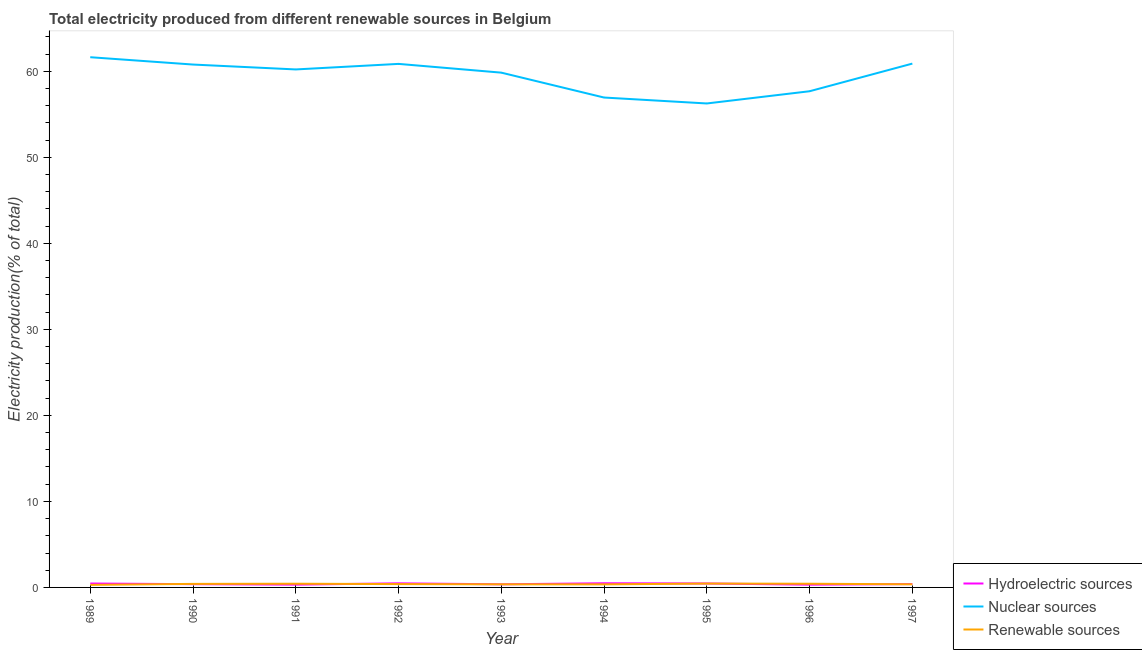How many different coloured lines are there?
Your answer should be very brief. 3. Does the line corresponding to percentage of electricity produced by nuclear sources intersect with the line corresponding to percentage of electricity produced by renewable sources?
Make the answer very short. No. What is the percentage of electricity produced by renewable sources in 1993?
Offer a terse response. 0.36. Across all years, what is the maximum percentage of electricity produced by hydroelectric sources?
Offer a very short reply. 0.48. Across all years, what is the minimum percentage of electricity produced by nuclear sources?
Your response must be concise. 56.25. In which year was the percentage of electricity produced by hydroelectric sources minimum?
Your answer should be very brief. 1996. What is the total percentage of electricity produced by renewable sources in the graph?
Ensure brevity in your answer.  3.48. What is the difference between the percentage of electricity produced by hydroelectric sources in 1991 and that in 1995?
Give a very brief answer. -0.14. What is the difference between the percentage of electricity produced by hydroelectric sources in 1995 and the percentage of electricity produced by nuclear sources in 1991?
Your answer should be very brief. -59.75. What is the average percentage of electricity produced by hydroelectric sources per year?
Make the answer very short. 0.41. In the year 1995, what is the difference between the percentage of electricity produced by hydroelectric sources and percentage of electricity produced by nuclear sources?
Offer a terse response. -55.79. What is the ratio of the percentage of electricity produced by hydroelectric sources in 1993 to that in 1996?
Give a very brief answer. 1.14. Is the percentage of electricity produced by renewable sources in 1992 less than that in 1995?
Your answer should be very brief. Yes. Is the difference between the percentage of electricity produced by nuclear sources in 1990 and 1991 greater than the difference between the percentage of electricity produced by hydroelectric sources in 1990 and 1991?
Offer a very short reply. Yes. What is the difference between the highest and the second highest percentage of electricity produced by nuclear sources?
Your response must be concise. 0.74. What is the difference between the highest and the lowest percentage of electricity produced by hydroelectric sources?
Make the answer very short. 0.17. Is the sum of the percentage of electricity produced by nuclear sources in 1990 and 1992 greater than the maximum percentage of electricity produced by renewable sources across all years?
Your answer should be very brief. Yes. Is it the case that in every year, the sum of the percentage of electricity produced by hydroelectric sources and percentage of electricity produced by nuclear sources is greater than the percentage of electricity produced by renewable sources?
Ensure brevity in your answer.  Yes. Does the percentage of electricity produced by nuclear sources monotonically increase over the years?
Your response must be concise. No. Is the percentage of electricity produced by renewable sources strictly greater than the percentage of electricity produced by hydroelectric sources over the years?
Provide a succinct answer. No. How many lines are there?
Your answer should be very brief. 3. Are the values on the major ticks of Y-axis written in scientific E-notation?
Provide a short and direct response. No. Does the graph contain any zero values?
Your answer should be very brief. No. Where does the legend appear in the graph?
Keep it short and to the point. Bottom right. How many legend labels are there?
Offer a terse response. 3. What is the title of the graph?
Offer a terse response. Total electricity produced from different renewable sources in Belgium. Does "Liquid fuel" appear as one of the legend labels in the graph?
Offer a very short reply. No. What is the label or title of the Y-axis?
Offer a terse response. Electricity production(% of total). What is the Electricity production(% of total) in Hydroelectric sources in 1989?
Offer a terse response. 0.46. What is the Electricity production(% of total) in Nuclear sources in 1989?
Keep it short and to the point. 61.63. What is the Electricity production(% of total) of Renewable sources in 1989?
Provide a short and direct response. 0.3. What is the Electricity production(% of total) of Hydroelectric sources in 1990?
Your response must be concise. 0.38. What is the Electricity production(% of total) of Nuclear sources in 1990?
Offer a very short reply. 60.78. What is the Electricity production(% of total) of Renewable sources in 1990?
Give a very brief answer. 0.41. What is the Electricity production(% of total) of Hydroelectric sources in 1991?
Ensure brevity in your answer.  0.32. What is the Electricity production(% of total) in Nuclear sources in 1991?
Offer a terse response. 60.21. What is the Electricity production(% of total) in Renewable sources in 1991?
Give a very brief answer. 0.43. What is the Electricity production(% of total) of Hydroelectric sources in 1992?
Offer a very short reply. 0.48. What is the Electricity production(% of total) of Nuclear sources in 1992?
Provide a succinct answer. 60.85. What is the Electricity production(% of total) of Renewable sources in 1992?
Offer a terse response. 0.39. What is the Electricity production(% of total) of Hydroelectric sources in 1993?
Ensure brevity in your answer.  0.36. What is the Electricity production(% of total) of Nuclear sources in 1993?
Your response must be concise. 59.84. What is the Electricity production(% of total) in Renewable sources in 1993?
Provide a succinct answer. 0.36. What is the Electricity production(% of total) in Hydroelectric sources in 1994?
Offer a terse response. 0.48. What is the Electricity production(% of total) in Nuclear sources in 1994?
Ensure brevity in your answer.  56.94. What is the Electricity production(% of total) of Renewable sources in 1994?
Make the answer very short. 0.36. What is the Electricity production(% of total) of Hydroelectric sources in 1995?
Offer a very short reply. 0.46. What is the Electricity production(% of total) in Nuclear sources in 1995?
Give a very brief answer. 56.25. What is the Electricity production(% of total) of Renewable sources in 1995?
Keep it short and to the point. 0.45. What is the Electricity production(% of total) in Hydroelectric sources in 1996?
Your answer should be compact. 0.32. What is the Electricity production(% of total) in Nuclear sources in 1996?
Ensure brevity in your answer.  57.68. What is the Electricity production(% of total) of Renewable sources in 1996?
Keep it short and to the point. 0.43. What is the Electricity production(% of total) in Hydroelectric sources in 1997?
Offer a terse response. 0.39. What is the Electricity production(% of total) of Nuclear sources in 1997?
Provide a short and direct response. 60.89. What is the Electricity production(% of total) in Renewable sources in 1997?
Your response must be concise. 0.36. Across all years, what is the maximum Electricity production(% of total) in Hydroelectric sources?
Your answer should be compact. 0.48. Across all years, what is the maximum Electricity production(% of total) in Nuclear sources?
Your answer should be compact. 61.63. Across all years, what is the maximum Electricity production(% of total) of Renewable sources?
Your response must be concise. 0.45. Across all years, what is the minimum Electricity production(% of total) in Hydroelectric sources?
Your response must be concise. 0.32. Across all years, what is the minimum Electricity production(% of total) of Nuclear sources?
Ensure brevity in your answer.  56.25. Across all years, what is the minimum Electricity production(% of total) of Renewable sources?
Offer a very short reply. 0.3. What is the total Electricity production(% of total) in Hydroelectric sources in the graph?
Keep it short and to the point. 3.65. What is the total Electricity production(% of total) of Nuclear sources in the graph?
Make the answer very short. 535.07. What is the total Electricity production(% of total) of Renewable sources in the graph?
Provide a short and direct response. 3.48. What is the difference between the Electricity production(% of total) in Hydroelectric sources in 1989 and that in 1990?
Provide a succinct answer. 0.08. What is the difference between the Electricity production(% of total) in Nuclear sources in 1989 and that in 1990?
Your answer should be compact. 0.85. What is the difference between the Electricity production(% of total) of Renewable sources in 1989 and that in 1990?
Provide a succinct answer. -0.12. What is the difference between the Electricity production(% of total) of Hydroelectric sources in 1989 and that in 1991?
Keep it short and to the point. 0.13. What is the difference between the Electricity production(% of total) in Nuclear sources in 1989 and that in 1991?
Ensure brevity in your answer.  1.42. What is the difference between the Electricity production(% of total) in Renewable sources in 1989 and that in 1991?
Ensure brevity in your answer.  -0.14. What is the difference between the Electricity production(% of total) of Hydroelectric sources in 1989 and that in 1992?
Offer a very short reply. -0.02. What is the difference between the Electricity production(% of total) in Nuclear sources in 1989 and that in 1992?
Provide a succinct answer. 0.78. What is the difference between the Electricity production(% of total) of Renewable sources in 1989 and that in 1992?
Your answer should be very brief. -0.09. What is the difference between the Electricity production(% of total) of Hydroelectric sources in 1989 and that in 1993?
Your answer should be very brief. 0.09. What is the difference between the Electricity production(% of total) of Nuclear sources in 1989 and that in 1993?
Make the answer very short. 1.79. What is the difference between the Electricity production(% of total) of Renewable sources in 1989 and that in 1993?
Provide a succinct answer. -0.07. What is the difference between the Electricity production(% of total) of Hydroelectric sources in 1989 and that in 1994?
Offer a very short reply. -0.03. What is the difference between the Electricity production(% of total) of Nuclear sources in 1989 and that in 1994?
Offer a terse response. 4.69. What is the difference between the Electricity production(% of total) of Renewable sources in 1989 and that in 1994?
Make the answer very short. -0.06. What is the difference between the Electricity production(% of total) in Hydroelectric sources in 1989 and that in 1995?
Offer a terse response. -0. What is the difference between the Electricity production(% of total) of Nuclear sources in 1989 and that in 1995?
Keep it short and to the point. 5.38. What is the difference between the Electricity production(% of total) of Renewable sources in 1989 and that in 1995?
Keep it short and to the point. -0.15. What is the difference between the Electricity production(% of total) in Hydroelectric sources in 1989 and that in 1996?
Make the answer very short. 0.14. What is the difference between the Electricity production(% of total) in Nuclear sources in 1989 and that in 1996?
Provide a short and direct response. 3.96. What is the difference between the Electricity production(% of total) in Renewable sources in 1989 and that in 1996?
Your answer should be very brief. -0.13. What is the difference between the Electricity production(% of total) of Hydroelectric sources in 1989 and that in 1997?
Provide a succinct answer. 0.06. What is the difference between the Electricity production(% of total) in Nuclear sources in 1989 and that in 1997?
Keep it short and to the point. 0.74. What is the difference between the Electricity production(% of total) of Renewable sources in 1989 and that in 1997?
Provide a succinct answer. -0.07. What is the difference between the Electricity production(% of total) of Hydroelectric sources in 1990 and that in 1991?
Provide a short and direct response. 0.06. What is the difference between the Electricity production(% of total) in Nuclear sources in 1990 and that in 1991?
Your answer should be compact. 0.57. What is the difference between the Electricity production(% of total) in Renewable sources in 1990 and that in 1991?
Offer a very short reply. -0.02. What is the difference between the Electricity production(% of total) of Hydroelectric sources in 1990 and that in 1992?
Your answer should be compact. -0.1. What is the difference between the Electricity production(% of total) of Nuclear sources in 1990 and that in 1992?
Your response must be concise. -0.08. What is the difference between the Electricity production(% of total) of Renewable sources in 1990 and that in 1992?
Make the answer very short. 0.02. What is the difference between the Electricity production(% of total) in Hydroelectric sources in 1990 and that in 1993?
Your response must be concise. 0.02. What is the difference between the Electricity production(% of total) of Nuclear sources in 1990 and that in 1993?
Provide a succinct answer. 0.94. What is the difference between the Electricity production(% of total) of Renewable sources in 1990 and that in 1993?
Offer a terse response. 0.05. What is the difference between the Electricity production(% of total) in Hydroelectric sources in 1990 and that in 1994?
Your answer should be very brief. -0.11. What is the difference between the Electricity production(% of total) in Nuclear sources in 1990 and that in 1994?
Make the answer very short. 3.83. What is the difference between the Electricity production(% of total) in Renewable sources in 1990 and that in 1994?
Offer a terse response. 0.06. What is the difference between the Electricity production(% of total) of Hydroelectric sources in 1990 and that in 1995?
Your answer should be compact. -0.08. What is the difference between the Electricity production(% of total) in Nuclear sources in 1990 and that in 1995?
Make the answer very short. 4.52. What is the difference between the Electricity production(% of total) of Renewable sources in 1990 and that in 1995?
Ensure brevity in your answer.  -0.04. What is the difference between the Electricity production(% of total) of Hydroelectric sources in 1990 and that in 1996?
Your answer should be compact. 0.06. What is the difference between the Electricity production(% of total) in Nuclear sources in 1990 and that in 1996?
Make the answer very short. 3.1. What is the difference between the Electricity production(% of total) of Renewable sources in 1990 and that in 1996?
Your answer should be very brief. -0.02. What is the difference between the Electricity production(% of total) in Hydroelectric sources in 1990 and that in 1997?
Provide a short and direct response. -0.01. What is the difference between the Electricity production(% of total) of Nuclear sources in 1990 and that in 1997?
Provide a succinct answer. -0.11. What is the difference between the Electricity production(% of total) in Renewable sources in 1990 and that in 1997?
Ensure brevity in your answer.  0.05. What is the difference between the Electricity production(% of total) in Hydroelectric sources in 1991 and that in 1992?
Offer a terse response. -0.16. What is the difference between the Electricity production(% of total) of Nuclear sources in 1991 and that in 1992?
Your answer should be compact. -0.64. What is the difference between the Electricity production(% of total) in Renewable sources in 1991 and that in 1992?
Provide a short and direct response. 0.04. What is the difference between the Electricity production(% of total) of Hydroelectric sources in 1991 and that in 1993?
Offer a terse response. -0.04. What is the difference between the Electricity production(% of total) of Nuclear sources in 1991 and that in 1993?
Provide a succinct answer. 0.37. What is the difference between the Electricity production(% of total) of Renewable sources in 1991 and that in 1993?
Offer a terse response. 0.07. What is the difference between the Electricity production(% of total) in Hydroelectric sources in 1991 and that in 1994?
Keep it short and to the point. -0.16. What is the difference between the Electricity production(% of total) of Nuclear sources in 1991 and that in 1994?
Offer a terse response. 3.27. What is the difference between the Electricity production(% of total) of Renewable sources in 1991 and that in 1994?
Give a very brief answer. 0.08. What is the difference between the Electricity production(% of total) in Hydroelectric sources in 1991 and that in 1995?
Your response must be concise. -0.14. What is the difference between the Electricity production(% of total) in Nuclear sources in 1991 and that in 1995?
Your answer should be very brief. 3.96. What is the difference between the Electricity production(% of total) of Renewable sources in 1991 and that in 1995?
Your answer should be compact. -0.02. What is the difference between the Electricity production(% of total) of Hydroelectric sources in 1991 and that in 1996?
Make the answer very short. 0. What is the difference between the Electricity production(% of total) in Nuclear sources in 1991 and that in 1996?
Ensure brevity in your answer.  2.53. What is the difference between the Electricity production(% of total) in Renewable sources in 1991 and that in 1996?
Provide a succinct answer. 0. What is the difference between the Electricity production(% of total) in Hydroelectric sources in 1991 and that in 1997?
Offer a very short reply. -0.07. What is the difference between the Electricity production(% of total) in Nuclear sources in 1991 and that in 1997?
Provide a succinct answer. -0.68. What is the difference between the Electricity production(% of total) of Renewable sources in 1991 and that in 1997?
Give a very brief answer. 0.07. What is the difference between the Electricity production(% of total) of Hydroelectric sources in 1992 and that in 1993?
Offer a terse response. 0.12. What is the difference between the Electricity production(% of total) of Nuclear sources in 1992 and that in 1993?
Your answer should be very brief. 1.02. What is the difference between the Electricity production(% of total) in Renewable sources in 1992 and that in 1993?
Ensure brevity in your answer.  0.03. What is the difference between the Electricity production(% of total) of Hydroelectric sources in 1992 and that in 1994?
Give a very brief answer. -0.01. What is the difference between the Electricity production(% of total) of Nuclear sources in 1992 and that in 1994?
Your answer should be very brief. 3.91. What is the difference between the Electricity production(% of total) of Renewable sources in 1992 and that in 1994?
Keep it short and to the point. 0.03. What is the difference between the Electricity production(% of total) in Hydroelectric sources in 1992 and that in 1995?
Your answer should be very brief. 0.02. What is the difference between the Electricity production(% of total) of Nuclear sources in 1992 and that in 1995?
Keep it short and to the point. 4.6. What is the difference between the Electricity production(% of total) in Renewable sources in 1992 and that in 1995?
Your response must be concise. -0.06. What is the difference between the Electricity production(% of total) in Hydroelectric sources in 1992 and that in 1996?
Give a very brief answer. 0.16. What is the difference between the Electricity production(% of total) in Nuclear sources in 1992 and that in 1996?
Your answer should be very brief. 3.18. What is the difference between the Electricity production(% of total) of Renewable sources in 1992 and that in 1996?
Your answer should be compact. -0.04. What is the difference between the Electricity production(% of total) in Hydroelectric sources in 1992 and that in 1997?
Make the answer very short. 0.09. What is the difference between the Electricity production(% of total) in Nuclear sources in 1992 and that in 1997?
Offer a terse response. -0.03. What is the difference between the Electricity production(% of total) of Renewable sources in 1992 and that in 1997?
Your answer should be compact. 0.02. What is the difference between the Electricity production(% of total) of Hydroelectric sources in 1993 and that in 1994?
Provide a short and direct response. -0.12. What is the difference between the Electricity production(% of total) in Nuclear sources in 1993 and that in 1994?
Offer a very short reply. 2.89. What is the difference between the Electricity production(% of total) in Renewable sources in 1993 and that in 1994?
Offer a very short reply. 0.01. What is the difference between the Electricity production(% of total) of Hydroelectric sources in 1993 and that in 1995?
Provide a succinct answer. -0.1. What is the difference between the Electricity production(% of total) in Nuclear sources in 1993 and that in 1995?
Your answer should be compact. 3.58. What is the difference between the Electricity production(% of total) in Renewable sources in 1993 and that in 1995?
Your answer should be compact. -0.09. What is the difference between the Electricity production(% of total) in Hydroelectric sources in 1993 and that in 1996?
Provide a succinct answer. 0.04. What is the difference between the Electricity production(% of total) of Nuclear sources in 1993 and that in 1996?
Give a very brief answer. 2.16. What is the difference between the Electricity production(% of total) of Renewable sources in 1993 and that in 1996?
Provide a succinct answer. -0.07. What is the difference between the Electricity production(% of total) of Hydroelectric sources in 1993 and that in 1997?
Make the answer very short. -0.03. What is the difference between the Electricity production(% of total) in Nuclear sources in 1993 and that in 1997?
Your answer should be compact. -1.05. What is the difference between the Electricity production(% of total) in Renewable sources in 1993 and that in 1997?
Your response must be concise. -0. What is the difference between the Electricity production(% of total) of Hydroelectric sources in 1994 and that in 1995?
Offer a terse response. 0.03. What is the difference between the Electricity production(% of total) in Nuclear sources in 1994 and that in 1995?
Your response must be concise. 0.69. What is the difference between the Electricity production(% of total) of Renewable sources in 1994 and that in 1995?
Keep it short and to the point. -0.09. What is the difference between the Electricity production(% of total) in Hydroelectric sources in 1994 and that in 1996?
Keep it short and to the point. 0.17. What is the difference between the Electricity production(% of total) of Nuclear sources in 1994 and that in 1996?
Your response must be concise. -0.73. What is the difference between the Electricity production(% of total) in Renewable sources in 1994 and that in 1996?
Provide a short and direct response. -0.07. What is the difference between the Electricity production(% of total) of Hydroelectric sources in 1994 and that in 1997?
Offer a terse response. 0.09. What is the difference between the Electricity production(% of total) in Nuclear sources in 1994 and that in 1997?
Provide a succinct answer. -3.94. What is the difference between the Electricity production(% of total) of Renewable sources in 1994 and that in 1997?
Provide a short and direct response. -0.01. What is the difference between the Electricity production(% of total) of Hydroelectric sources in 1995 and that in 1996?
Make the answer very short. 0.14. What is the difference between the Electricity production(% of total) in Nuclear sources in 1995 and that in 1996?
Your answer should be compact. -1.42. What is the difference between the Electricity production(% of total) of Renewable sources in 1995 and that in 1996?
Provide a succinct answer. 0.02. What is the difference between the Electricity production(% of total) of Hydroelectric sources in 1995 and that in 1997?
Offer a terse response. 0.07. What is the difference between the Electricity production(% of total) in Nuclear sources in 1995 and that in 1997?
Your response must be concise. -4.63. What is the difference between the Electricity production(% of total) of Renewable sources in 1995 and that in 1997?
Offer a very short reply. 0.09. What is the difference between the Electricity production(% of total) in Hydroelectric sources in 1996 and that in 1997?
Ensure brevity in your answer.  -0.07. What is the difference between the Electricity production(% of total) in Nuclear sources in 1996 and that in 1997?
Offer a very short reply. -3.21. What is the difference between the Electricity production(% of total) in Renewable sources in 1996 and that in 1997?
Give a very brief answer. 0.07. What is the difference between the Electricity production(% of total) in Hydroelectric sources in 1989 and the Electricity production(% of total) in Nuclear sources in 1990?
Ensure brevity in your answer.  -60.32. What is the difference between the Electricity production(% of total) in Hydroelectric sources in 1989 and the Electricity production(% of total) in Renewable sources in 1990?
Keep it short and to the point. 0.04. What is the difference between the Electricity production(% of total) in Nuclear sources in 1989 and the Electricity production(% of total) in Renewable sources in 1990?
Offer a very short reply. 61.22. What is the difference between the Electricity production(% of total) in Hydroelectric sources in 1989 and the Electricity production(% of total) in Nuclear sources in 1991?
Offer a terse response. -59.75. What is the difference between the Electricity production(% of total) of Hydroelectric sources in 1989 and the Electricity production(% of total) of Renewable sources in 1991?
Provide a short and direct response. 0.02. What is the difference between the Electricity production(% of total) of Nuclear sources in 1989 and the Electricity production(% of total) of Renewable sources in 1991?
Your response must be concise. 61.2. What is the difference between the Electricity production(% of total) in Hydroelectric sources in 1989 and the Electricity production(% of total) in Nuclear sources in 1992?
Provide a short and direct response. -60.4. What is the difference between the Electricity production(% of total) of Hydroelectric sources in 1989 and the Electricity production(% of total) of Renewable sources in 1992?
Offer a very short reply. 0.07. What is the difference between the Electricity production(% of total) in Nuclear sources in 1989 and the Electricity production(% of total) in Renewable sources in 1992?
Your answer should be very brief. 61.24. What is the difference between the Electricity production(% of total) of Hydroelectric sources in 1989 and the Electricity production(% of total) of Nuclear sources in 1993?
Provide a short and direct response. -59.38. What is the difference between the Electricity production(% of total) in Hydroelectric sources in 1989 and the Electricity production(% of total) in Renewable sources in 1993?
Keep it short and to the point. 0.1. What is the difference between the Electricity production(% of total) of Nuclear sources in 1989 and the Electricity production(% of total) of Renewable sources in 1993?
Your answer should be very brief. 61.27. What is the difference between the Electricity production(% of total) of Hydroelectric sources in 1989 and the Electricity production(% of total) of Nuclear sources in 1994?
Provide a succinct answer. -56.49. What is the difference between the Electricity production(% of total) of Nuclear sources in 1989 and the Electricity production(% of total) of Renewable sources in 1994?
Your answer should be very brief. 61.27. What is the difference between the Electricity production(% of total) in Hydroelectric sources in 1989 and the Electricity production(% of total) in Nuclear sources in 1995?
Your answer should be compact. -55.8. What is the difference between the Electricity production(% of total) of Hydroelectric sources in 1989 and the Electricity production(% of total) of Renewable sources in 1995?
Provide a succinct answer. 0.01. What is the difference between the Electricity production(% of total) in Nuclear sources in 1989 and the Electricity production(% of total) in Renewable sources in 1995?
Give a very brief answer. 61.18. What is the difference between the Electricity production(% of total) of Hydroelectric sources in 1989 and the Electricity production(% of total) of Nuclear sources in 1996?
Your response must be concise. -57.22. What is the difference between the Electricity production(% of total) of Hydroelectric sources in 1989 and the Electricity production(% of total) of Renewable sources in 1996?
Your response must be concise. 0.03. What is the difference between the Electricity production(% of total) of Nuclear sources in 1989 and the Electricity production(% of total) of Renewable sources in 1996?
Give a very brief answer. 61.2. What is the difference between the Electricity production(% of total) in Hydroelectric sources in 1989 and the Electricity production(% of total) in Nuclear sources in 1997?
Give a very brief answer. -60.43. What is the difference between the Electricity production(% of total) of Hydroelectric sources in 1989 and the Electricity production(% of total) of Renewable sources in 1997?
Offer a very short reply. 0.09. What is the difference between the Electricity production(% of total) of Nuclear sources in 1989 and the Electricity production(% of total) of Renewable sources in 1997?
Give a very brief answer. 61.27. What is the difference between the Electricity production(% of total) in Hydroelectric sources in 1990 and the Electricity production(% of total) in Nuclear sources in 1991?
Offer a terse response. -59.83. What is the difference between the Electricity production(% of total) of Hydroelectric sources in 1990 and the Electricity production(% of total) of Renewable sources in 1991?
Your answer should be compact. -0.05. What is the difference between the Electricity production(% of total) in Nuclear sources in 1990 and the Electricity production(% of total) in Renewable sources in 1991?
Offer a terse response. 60.35. What is the difference between the Electricity production(% of total) in Hydroelectric sources in 1990 and the Electricity production(% of total) in Nuclear sources in 1992?
Offer a terse response. -60.48. What is the difference between the Electricity production(% of total) in Hydroelectric sources in 1990 and the Electricity production(% of total) in Renewable sources in 1992?
Ensure brevity in your answer.  -0.01. What is the difference between the Electricity production(% of total) of Nuclear sources in 1990 and the Electricity production(% of total) of Renewable sources in 1992?
Your answer should be compact. 60.39. What is the difference between the Electricity production(% of total) of Hydroelectric sources in 1990 and the Electricity production(% of total) of Nuclear sources in 1993?
Your response must be concise. -59.46. What is the difference between the Electricity production(% of total) in Hydroelectric sources in 1990 and the Electricity production(% of total) in Renewable sources in 1993?
Give a very brief answer. 0.02. What is the difference between the Electricity production(% of total) in Nuclear sources in 1990 and the Electricity production(% of total) in Renewable sources in 1993?
Provide a succinct answer. 60.42. What is the difference between the Electricity production(% of total) in Hydroelectric sources in 1990 and the Electricity production(% of total) in Nuclear sources in 1994?
Offer a terse response. -56.56. What is the difference between the Electricity production(% of total) of Hydroelectric sources in 1990 and the Electricity production(% of total) of Renewable sources in 1994?
Your answer should be very brief. 0.02. What is the difference between the Electricity production(% of total) of Nuclear sources in 1990 and the Electricity production(% of total) of Renewable sources in 1994?
Ensure brevity in your answer.  60.42. What is the difference between the Electricity production(% of total) of Hydroelectric sources in 1990 and the Electricity production(% of total) of Nuclear sources in 1995?
Your response must be concise. -55.88. What is the difference between the Electricity production(% of total) in Hydroelectric sources in 1990 and the Electricity production(% of total) in Renewable sources in 1995?
Offer a terse response. -0.07. What is the difference between the Electricity production(% of total) in Nuclear sources in 1990 and the Electricity production(% of total) in Renewable sources in 1995?
Your answer should be compact. 60.33. What is the difference between the Electricity production(% of total) in Hydroelectric sources in 1990 and the Electricity production(% of total) in Nuclear sources in 1996?
Your answer should be very brief. -57.3. What is the difference between the Electricity production(% of total) of Hydroelectric sources in 1990 and the Electricity production(% of total) of Renewable sources in 1996?
Your response must be concise. -0.05. What is the difference between the Electricity production(% of total) in Nuclear sources in 1990 and the Electricity production(% of total) in Renewable sources in 1996?
Your answer should be compact. 60.35. What is the difference between the Electricity production(% of total) in Hydroelectric sources in 1990 and the Electricity production(% of total) in Nuclear sources in 1997?
Provide a short and direct response. -60.51. What is the difference between the Electricity production(% of total) in Hydroelectric sources in 1990 and the Electricity production(% of total) in Renewable sources in 1997?
Your answer should be compact. 0.01. What is the difference between the Electricity production(% of total) in Nuclear sources in 1990 and the Electricity production(% of total) in Renewable sources in 1997?
Provide a succinct answer. 60.41. What is the difference between the Electricity production(% of total) in Hydroelectric sources in 1991 and the Electricity production(% of total) in Nuclear sources in 1992?
Make the answer very short. -60.53. What is the difference between the Electricity production(% of total) of Hydroelectric sources in 1991 and the Electricity production(% of total) of Renewable sources in 1992?
Offer a terse response. -0.06. What is the difference between the Electricity production(% of total) of Nuclear sources in 1991 and the Electricity production(% of total) of Renewable sources in 1992?
Offer a very short reply. 59.82. What is the difference between the Electricity production(% of total) of Hydroelectric sources in 1991 and the Electricity production(% of total) of Nuclear sources in 1993?
Ensure brevity in your answer.  -59.52. What is the difference between the Electricity production(% of total) of Hydroelectric sources in 1991 and the Electricity production(% of total) of Renewable sources in 1993?
Your response must be concise. -0.04. What is the difference between the Electricity production(% of total) of Nuclear sources in 1991 and the Electricity production(% of total) of Renewable sources in 1993?
Your response must be concise. 59.85. What is the difference between the Electricity production(% of total) in Hydroelectric sources in 1991 and the Electricity production(% of total) in Nuclear sources in 1994?
Give a very brief answer. -56.62. What is the difference between the Electricity production(% of total) in Hydroelectric sources in 1991 and the Electricity production(% of total) in Renewable sources in 1994?
Offer a terse response. -0.03. What is the difference between the Electricity production(% of total) in Nuclear sources in 1991 and the Electricity production(% of total) in Renewable sources in 1994?
Your answer should be very brief. 59.85. What is the difference between the Electricity production(% of total) of Hydroelectric sources in 1991 and the Electricity production(% of total) of Nuclear sources in 1995?
Offer a very short reply. -55.93. What is the difference between the Electricity production(% of total) in Hydroelectric sources in 1991 and the Electricity production(% of total) in Renewable sources in 1995?
Offer a very short reply. -0.13. What is the difference between the Electricity production(% of total) in Nuclear sources in 1991 and the Electricity production(% of total) in Renewable sources in 1995?
Offer a very short reply. 59.76. What is the difference between the Electricity production(% of total) of Hydroelectric sources in 1991 and the Electricity production(% of total) of Nuclear sources in 1996?
Offer a terse response. -57.35. What is the difference between the Electricity production(% of total) in Hydroelectric sources in 1991 and the Electricity production(% of total) in Renewable sources in 1996?
Offer a very short reply. -0.11. What is the difference between the Electricity production(% of total) of Nuclear sources in 1991 and the Electricity production(% of total) of Renewable sources in 1996?
Provide a succinct answer. 59.78. What is the difference between the Electricity production(% of total) of Hydroelectric sources in 1991 and the Electricity production(% of total) of Nuclear sources in 1997?
Your response must be concise. -60.57. What is the difference between the Electricity production(% of total) of Hydroelectric sources in 1991 and the Electricity production(% of total) of Renewable sources in 1997?
Your answer should be compact. -0.04. What is the difference between the Electricity production(% of total) in Nuclear sources in 1991 and the Electricity production(% of total) in Renewable sources in 1997?
Provide a short and direct response. 59.85. What is the difference between the Electricity production(% of total) in Hydroelectric sources in 1992 and the Electricity production(% of total) in Nuclear sources in 1993?
Keep it short and to the point. -59.36. What is the difference between the Electricity production(% of total) of Hydroelectric sources in 1992 and the Electricity production(% of total) of Renewable sources in 1993?
Keep it short and to the point. 0.12. What is the difference between the Electricity production(% of total) in Nuclear sources in 1992 and the Electricity production(% of total) in Renewable sources in 1993?
Your response must be concise. 60.49. What is the difference between the Electricity production(% of total) in Hydroelectric sources in 1992 and the Electricity production(% of total) in Nuclear sources in 1994?
Provide a short and direct response. -56.47. What is the difference between the Electricity production(% of total) of Hydroelectric sources in 1992 and the Electricity production(% of total) of Renewable sources in 1994?
Ensure brevity in your answer.  0.12. What is the difference between the Electricity production(% of total) of Nuclear sources in 1992 and the Electricity production(% of total) of Renewable sources in 1994?
Your answer should be compact. 60.5. What is the difference between the Electricity production(% of total) of Hydroelectric sources in 1992 and the Electricity production(% of total) of Nuclear sources in 1995?
Provide a short and direct response. -55.78. What is the difference between the Electricity production(% of total) in Hydroelectric sources in 1992 and the Electricity production(% of total) in Renewable sources in 1995?
Your answer should be compact. 0.03. What is the difference between the Electricity production(% of total) in Nuclear sources in 1992 and the Electricity production(% of total) in Renewable sources in 1995?
Ensure brevity in your answer.  60.41. What is the difference between the Electricity production(% of total) of Hydroelectric sources in 1992 and the Electricity production(% of total) of Nuclear sources in 1996?
Make the answer very short. -57.2. What is the difference between the Electricity production(% of total) of Hydroelectric sources in 1992 and the Electricity production(% of total) of Renewable sources in 1996?
Offer a terse response. 0.05. What is the difference between the Electricity production(% of total) in Nuclear sources in 1992 and the Electricity production(% of total) in Renewable sources in 1996?
Offer a terse response. 60.43. What is the difference between the Electricity production(% of total) in Hydroelectric sources in 1992 and the Electricity production(% of total) in Nuclear sources in 1997?
Keep it short and to the point. -60.41. What is the difference between the Electricity production(% of total) of Hydroelectric sources in 1992 and the Electricity production(% of total) of Renewable sources in 1997?
Your answer should be compact. 0.11. What is the difference between the Electricity production(% of total) in Nuclear sources in 1992 and the Electricity production(% of total) in Renewable sources in 1997?
Provide a succinct answer. 60.49. What is the difference between the Electricity production(% of total) in Hydroelectric sources in 1993 and the Electricity production(% of total) in Nuclear sources in 1994?
Make the answer very short. -56.58. What is the difference between the Electricity production(% of total) of Hydroelectric sources in 1993 and the Electricity production(% of total) of Renewable sources in 1994?
Give a very brief answer. 0.01. What is the difference between the Electricity production(% of total) in Nuclear sources in 1993 and the Electricity production(% of total) in Renewable sources in 1994?
Your response must be concise. 59.48. What is the difference between the Electricity production(% of total) in Hydroelectric sources in 1993 and the Electricity production(% of total) in Nuclear sources in 1995?
Your answer should be very brief. -55.89. What is the difference between the Electricity production(% of total) in Hydroelectric sources in 1993 and the Electricity production(% of total) in Renewable sources in 1995?
Make the answer very short. -0.09. What is the difference between the Electricity production(% of total) of Nuclear sources in 1993 and the Electricity production(% of total) of Renewable sources in 1995?
Offer a terse response. 59.39. What is the difference between the Electricity production(% of total) in Hydroelectric sources in 1993 and the Electricity production(% of total) in Nuclear sources in 1996?
Keep it short and to the point. -57.31. What is the difference between the Electricity production(% of total) in Hydroelectric sources in 1993 and the Electricity production(% of total) in Renewable sources in 1996?
Make the answer very short. -0.07. What is the difference between the Electricity production(% of total) in Nuclear sources in 1993 and the Electricity production(% of total) in Renewable sources in 1996?
Offer a terse response. 59.41. What is the difference between the Electricity production(% of total) of Hydroelectric sources in 1993 and the Electricity production(% of total) of Nuclear sources in 1997?
Provide a short and direct response. -60.53. What is the difference between the Electricity production(% of total) in Hydroelectric sources in 1993 and the Electricity production(% of total) in Renewable sources in 1997?
Your answer should be very brief. -0. What is the difference between the Electricity production(% of total) in Nuclear sources in 1993 and the Electricity production(% of total) in Renewable sources in 1997?
Your response must be concise. 59.47. What is the difference between the Electricity production(% of total) of Hydroelectric sources in 1994 and the Electricity production(% of total) of Nuclear sources in 1995?
Your answer should be very brief. -55.77. What is the difference between the Electricity production(% of total) of Hydroelectric sources in 1994 and the Electricity production(% of total) of Renewable sources in 1995?
Ensure brevity in your answer.  0.04. What is the difference between the Electricity production(% of total) in Nuclear sources in 1994 and the Electricity production(% of total) in Renewable sources in 1995?
Provide a succinct answer. 56.49. What is the difference between the Electricity production(% of total) of Hydroelectric sources in 1994 and the Electricity production(% of total) of Nuclear sources in 1996?
Your response must be concise. -57.19. What is the difference between the Electricity production(% of total) in Hydroelectric sources in 1994 and the Electricity production(% of total) in Renewable sources in 1996?
Give a very brief answer. 0.06. What is the difference between the Electricity production(% of total) in Nuclear sources in 1994 and the Electricity production(% of total) in Renewable sources in 1996?
Keep it short and to the point. 56.51. What is the difference between the Electricity production(% of total) in Hydroelectric sources in 1994 and the Electricity production(% of total) in Nuclear sources in 1997?
Provide a short and direct response. -60.4. What is the difference between the Electricity production(% of total) of Hydroelectric sources in 1994 and the Electricity production(% of total) of Renewable sources in 1997?
Your response must be concise. 0.12. What is the difference between the Electricity production(% of total) in Nuclear sources in 1994 and the Electricity production(% of total) in Renewable sources in 1997?
Ensure brevity in your answer.  56.58. What is the difference between the Electricity production(% of total) of Hydroelectric sources in 1995 and the Electricity production(% of total) of Nuclear sources in 1996?
Your answer should be compact. -57.22. What is the difference between the Electricity production(% of total) in Hydroelectric sources in 1995 and the Electricity production(% of total) in Renewable sources in 1996?
Make the answer very short. 0.03. What is the difference between the Electricity production(% of total) in Nuclear sources in 1995 and the Electricity production(% of total) in Renewable sources in 1996?
Provide a succinct answer. 55.83. What is the difference between the Electricity production(% of total) in Hydroelectric sources in 1995 and the Electricity production(% of total) in Nuclear sources in 1997?
Provide a short and direct response. -60.43. What is the difference between the Electricity production(% of total) in Hydroelectric sources in 1995 and the Electricity production(% of total) in Renewable sources in 1997?
Make the answer very short. 0.1. What is the difference between the Electricity production(% of total) in Nuclear sources in 1995 and the Electricity production(% of total) in Renewable sources in 1997?
Ensure brevity in your answer.  55.89. What is the difference between the Electricity production(% of total) in Hydroelectric sources in 1996 and the Electricity production(% of total) in Nuclear sources in 1997?
Provide a short and direct response. -60.57. What is the difference between the Electricity production(% of total) in Hydroelectric sources in 1996 and the Electricity production(% of total) in Renewable sources in 1997?
Ensure brevity in your answer.  -0.05. What is the difference between the Electricity production(% of total) in Nuclear sources in 1996 and the Electricity production(% of total) in Renewable sources in 1997?
Ensure brevity in your answer.  57.31. What is the average Electricity production(% of total) in Hydroelectric sources per year?
Give a very brief answer. 0.41. What is the average Electricity production(% of total) in Nuclear sources per year?
Your answer should be compact. 59.45. What is the average Electricity production(% of total) of Renewable sources per year?
Make the answer very short. 0.39. In the year 1989, what is the difference between the Electricity production(% of total) in Hydroelectric sources and Electricity production(% of total) in Nuclear sources?
Offer a terse response. -61.17. In the year 1989, what is the difference between the Electricity production(% of total) in Hydroelectric sources and Electricity production(% of total) in Renewable sources?
Your answer should be compact. 0.16. In the year 1989, what is the difference between the Electricity production(% of total) in Nuclear sources and Electricity production(% of total) in Renewable sources?
Offer a terse response. 61.34. In the year 1990, what is the difference between the Electricity production(% of total) in Hydroelectric sources and Electricity production(% of total) in Nuclear sources?
Offer a very short reply. -60.4. In the year 1990, what is the difference between the Electricity production(% of total) in Hydroelectric sources and Electricity production(% of total) in Renewable sources?
Your response must be concise. -0.03. In the year 1990, what is the difference between the Electricity production(% of total) in Nuclear sources and Electricity production(% of total) in Renewable sources?
Ensure brevity in your answer.  60.37. In the year 1991, what is the difference between the Electricity production(% of total) of Hydroelectric sources and Electricity production(% of total) of Nuclear sources?
Give a very brief answer. -59.89. In the year 1991, what is the difference between the Electricity production(% of total) of Hydroelectric sources and Electricity production(% of total) of Renewable sources?
Offer a very short reply. -0.11. In the year 1991, what is the difference between the Electricity production(% of total) of Nuclear sources and Electricity production(% of total) of Renewable sources?
Give a very brief answer. 59.78. In the year 1992, what is the difference between the Electricity production(% of total) in Hydroelectric sources and Electricity production(% of total) in Nuclear sources?
Make the answer very short. -60.38. In the year 1992, what is the difference between the Electricity production(% of total) of Hydroelectric sources and Electricity production(% of total) of Renewable sources?
Your answer should be compact. 0.09. In the year 1992, what is the difference between the Electricity production(% of total) in Nuclear sources and Electricity production(% of total) in Renewable sources?
Provide a succinct answer. 60.47. In the year 1993, what is the difference between the Electricity production(% of total) of Hydroelectric sources and Electricity production(% of total) of Nuclear sources?
Provide a short and direct response. -59.48. In the year 1993, what is the difference between the Electricity production(% of total) of Hydroelectric sources and Electricity production(% of total) of Renewable sources?
Offer a terse response. 0. In the year 1993, what is the difference between the Electricity production(% of total) of Nuclear sources and Electricity production(% of total) of Renewable sources?
Offer a terse response. 59.48. In the year 1994, what is the difference between the Electricity production(% of total) of Hydroelectric sources and Electricity production(% of total) of Nuclear sources?
Give a very brief answer. -56.46. In the year 1994, what is the difference between the Electricity production(% of total) of Hydroelectric sources and Electricity production(% of total) of Renewable sources?
Your answer should be very brief. 0.13. In the year 1994, what is the difference between the Electricity production(% of total) of Nuclear sources and Electricity production(% of total) of Renewable sources?
Provide a succinct answer. 56.59. In the year 1995, what is the difference between the Electricity production(% of total) of Hydroelectric sources and Electricity production(% of total) of Nuclear sources?
Provide a succinct answer. -55.79. In the year 1995, what is the difference between the Electricity production(% of total) of Hydroelectric sources and Electricity production(% of total) of Renewable sources?
Your response must be concise. 0.01. In the year 1995, what is the difference between the Electricity production(% of total) in Nuclear sources and Electricity production(% of total) in Renewable sources?
Give a very brief answer. 55.81. In the year 1996, what is the difference between the Electricity production(% of total) in Hydroelectric sources and Electricity production(% of total) in Nuclear sources?
Give a very brief answer. -57.36. In the year 1996, what is the difference between the Electricity production(% of total) in Hydroelectric sources and Electricity production(% of total) in Renewable sources?
Give a very brief answer. -0.11. In the year 1996, what is the difference between the Electricity production(% of total) in Nuclear sources and Electricity production(% of total) in Renewable sources?
Offer a terse response. 57.25. In the year 1997, what is the difference between the Electricity production(% of total) of Hydroelectric sources and Electricity production(% of total) of Nuclear sources?
Provide a short and direct response. -60.5. In the year 1997, what is the difference between the Electricity production(% of total) in Hydroelectric sources and Electricity production(% of total) in Renewable sources?
Offer a very short reply. 0.03. In the year 1997, what is the difference between the Electricity production(% of total) in Nuclear sources and Electricity production(% of total) in Renewable sources?
Your response must be concise. 60.52. What is the ratio of the Electricity production(% of total) in Hydroelectric sources in 1989 to that in 1990?
Give a very brief answer. 1.21. What is the ratio of the Electricity production(% of total) of Nuclear sources in 1989 to that in 1990?
Give a very brief answer. 1.01. What is the ratio of the Electricity production(% of total) in Renewable sources in 1989 to that in 1990?
Make the answer very short. 0.72. What is the ratio of the Electricity production(% of total) of Hydroelectric sources in 1989 to that in 1991?
Offer a very short reply. 1.42. What is the ratio of the Electricity production(% of total) of Nuclear sources in 1989 to that in 1991?
Provide a short and direct response. 1.02. What is the ratio of the Electricity production(% of total) of Renewable sources in 1989 to that in 1991?
Your answer should be very brief. 0.69. What is the ratio of the Electricity production(% of total) of Hydroelectric sources in 1989 to that in 1992?
Keep it short and to the point. 0.96. What is the ratio of the Electricity production(% of total) in Nuclear sources in 1989 to that in 1992?
Make the answer very short. 1.01. What is the ratio of the Electricity production(% of total) of Renewable sources in 1989 to that in 1992?
Provide a short and direct response. 0.77. What is the ratio of the Electricity production(% of total) of Hydroelectric sources in 1989 to that in 1993?
Your response must be concise. 1.26. What is the ratio of the Electricity production(% of total) in Nuclear sources in 1989 to that in 1993?
Your answer should be compact. 1.03. What is the ratio of the Electricity production(% of total) in Renewable sources in 1989 to that in 1993?
Provide a short and direct response. 0.82. What is the ratio of the Electricity production(% of total) of Hydroelectric sources in 1989 to that in 1994?
Keep it short and to the point. 0.94. What is the ratio of the Electricity production(% of total) in Nuclear sources in 1989 to that in 1994?
Give a very brief answer. 1.08. What is the ratio of the Electricity production(% of total) of Renewable sources in 1989 to that in 1994?
Your response must be concise. 0.83. What is the ratio of the Electricity production(% of total) of Hydroelectric sources in 1989 to that in 1995?
Keep it short and to the point. 0.99. What is the ratio of the Electricity production(% of total) of Nuclear sources in 1989 to that in 1995?
Provide a succinct answer. 1.1. What is the ratio of the Electricity production(% of total) in Renewable sources in 1989 to that in 1995?
Provide a succinct answer. 0.66. What is the ratio of the Electricity production(% of total) of Hydroelectric sources in 1989 to that in 1996?
Your answer should be compact. 1.43. What is the ratio of the Electricity production(% of total) in Nuclear sources in 1989 to that in 1996?
Offer a very short reply. 1.07. What is the ratio of the Electricity production(% of total) of Renewable sources in 1989 to that in 1996?
Give a very brief answer. 0.69. What is the ratio of the Electricity production(% of total) of Hydroelectric sources in 1989 to that in 1997?
Your answer should be very brief. 1.16. What is the ratio of the Electricity production(% of total) in Nuclear sources in 1989 to that in 1997?
Your response must be concise. 1.01. What is the ratio of the Electricity production(% of total) in Renewable sources in 1989 to that in 1997?
Make the answer very short. 0.81. What is the ratio of the Electricity production(% of total) of Hydroelectric sources in 1990 to that in 1991?
Provide a succinct answer. 1.18. What is the ratio of the Electricity production(% of total) of Nuclear sources in 1990 to that in 1991?
Provide a succinct answer. 1.01. What is the ratio of the Electricity production(% of total) of Renewable sources in 1990 to that in 1991?
Give a very brief answer. 0.95. What is the ratio of the Electricity production(% of total) of Hydroelectric sources in 1990 to that in 1992?
Give a very brief answer. 0.79. What is the ratio of the Electricity production(% of total) in Nuclear sources in 1990 to that in 1992?
Keep it short and to the point. 1. What is the ratio of the Electricity production(% of total) of Renewable sources in 1990 to that in 1992?
Provide a short and direct response. 1.06. What is the ratio of the Electricity production(% of total) in Hydroelectric sources in 1990 to that in 1993?
Ensure brevity in your answer.  1.04. What is the ratio of the Electricity production(% of total) in Nuclear sources in 1990 to that in 1993?
Keep it short and to the point. 1.02. What is the ratio of the Electricity production(% of total) in Renewable sources in 1990 to that in 1993?
Provide a succinct answer. 1.14. What is the ratio of the Electricity production(% of total) of Hydroelectric sources in 1990 to that in 1994?
Offer a very short reply. 0.78. What is the ratio of the Electricity production(% of total) in Nuclear sources in 1990 to that in 1994?
Your response must be concise. 1.07. What is the ratio of the Electricity production(% of total) in Renewable sources in 1990 to that in 1994?
Make the answer very short. 1.15. What is the ratio of the Electricity production(% of total) of Hydroelectric sources in 1990 to that in 1995?
Provide a short and direct response. 0.82. What is the ratio of the Electricity production(% of total) in Nuclear sources in 1990 to that in 1995?
Your answer should be compact. 1.08. What is the ratio of the Electricity production(% of total) of Renewable sources in 1990 to that in 1995?
Your answer should be compact. 0.92. What is the ratio of the Electricity production(% of total) of Hydroelectric sources in 1990 to that in 1996?
Your response must be concise. 1.19. What is the ratio of the Electricity production(% of total) in Nuclear sources in 1990 to that in 1996?
Offer a very short reply. 1.05. What is the ratio of the Electricity production(% of total) in Renewable sources in 1990 to that in 1996?
Offer a very short reply. 0.96. What is the ratio of the Electricity production(% of total) in Hydroelectric sources in 1990 to that in 1997?
Make the answer very short. 0.97. What is the ratio of the Electricity production(% of total) of Renewable sources in 1990 to that in 1997?
Ensure brevity in your answer.  1.13. What is the ratio of the Electricity production(% of total) of Hydroelectric sources in 1991 to that in 1992?
Offer a terse response. 0.67. What is the ratio of the Electricity production(% of total) of Nuclear sources in 1991 to that in 1992?
Your response must be concise. 0.99. What is the ratio of the Electricity production(% of total) of Renewable sources in 1991 to that in 1992?
Offer a very short reply. 1.12. What is the ratio of the Electricity production(% of total) of Hydroelectric sources in 1991 to that in 1993?
Give a very brief answer. 0.89. What is the ratio of the Electricity production(% of total) of Renewable sources in 1991 to that in 1993?
Your answer should be compact. 1.19. What is the ratio of the Electricity production(% of total) in Hydroelectric sources in 1991 to that in 1994?
Provide a succinct answer. 0.66. What is the ratio of the Electricity production(% of total) in Nuclear sources in 1991 to that in 1994?
Give a very brief answer. 1.06. What is the ratio of the Electricity production(% of total) of Renewable sources in 1991 to that in 1994?
Provide a short and direct response. 1.21. What is the ratio of the Electricity production(% of total) of Hydroelectric sources in 1991 to that in 1995?
Your answer should be compact. 0.7. What is the ratio of the Electricity production(% of total) of Nuclear sources in 1991 to that in 1995?
Make the answer very short. 1.07. What is the ratio of the Electricity production(% of total) of Renewable sources in 1991 to that in 1995?
Your answer should be compact. 0.96. What is the ratio of the Electricity production(% of total) in Hydroelectric sources in 1991 to that in 1996?
Ensure brevity in your answer.  1.01. What is the ratio of the Electricity production(% of total) of Nuclear sources in 1991 to that in 1996?
Keep it short and to the point. 1.04. What is the ratio of the Electricity production(% of total) of Hydroelectric sources in 1991 to that in 1997?
Offer a terse response. 0.82. What is the ratio of the Electricity production(% of total) in Nuclear sources in 1991 to that in 1997?
Make the answer very short. 0.99. What is the ratio of the Electricity production(% of total) of Renewable sources in 1991 to that in 1997?
Your answer should be compact. 1.19. What is the ratio of the Electricity production(% of total) of Hydroelectric sources in 1992 to that in 1993?
Your response must be concise. 1.32. What is the ratio of the Electricity production(% of total) of Nuclear sources in 1992 to that in 1993?
Offer a terse response. 1.02. What is the ratio of the Electricity production(% of total) in Renewable sources in 1992 to that in 1993?
Your answer should be very brief. 1.07. What is the ratio of the Electricity production(% of total) in Hydroelectric sources in 1992 to that in 1994?
Offer a terse response. 0.98. What is the ratio of the Electricity production(% of total) in Nuclear sources in 1992 to that in 1994?
Your response must be concise. 1.07. What is the ratio of the Electricity production(% of total) of Renewable sources in 1992 to that in 1994?
Provide a short and direct response. 1.09. What is the ratio of the Electricity production(% of total) of Hydroelectric sources in 1992 to that in 1995?
Your response must be concise. 1.04. What is the ratio of the Electricity production(% of total) of Nuclear sources in 1992 to that in 1995?
Provide a short and direct response. 1.08. What is the ratio of the Electricity production(% of total) in Renewable sources in 1992 to that in 1995?
Your answer should be compact. 0.86. What is the ratio of the Electricity production(% of total) of Hydroelectric sources in 1992 to that in 1996?
Your response must be concise. 1.5. What is the ratio of the Electricity production(% of total) in Nuclear sources in 1992 to that in 1996?
Your response must be concise. 1.06. What is the ratio of the Electricity production(% of total) in Renewable sources in 1992 to that in 1996?
Provide a succinct answer. 0.9. What is the ratio of the Electricity production(% of total) of Hydroelectric sources in 1992 to that in 1997?
Your answer should be very brief. 1.22. What is the ratio of the Electricity production(% of total) of Renewable sources in 1992 to that in 1997?
Keep it short and to the point. 1.06. What is the ratio of the Electricity production(% of total) in Hydroelectric sources in 1993 to that in 1994?
Provide a succinct answer. 0.75. What is the ratio of the Electricity production(% of total) in Nuclear sources in 1993 to that in 1994?
Keep it short and to the point. 1.05. What is the ratio of the Electricity production(% of total) of Renewable sources in 1993 to that in 1994?
Keep it short and to the point. 1.01. What is the ratio of the Electricity production(% of total) of Hydroelectric sources in 1993 to that in 1995?
Provide a short and direct response. 0.79. What is the ratio of the Electricity production(% of total) of Nuclear sources in 1993 to that in 1995?
Give a very brief answer. 1.06. What is the ratio of the Electricity production(% of total) in Renewable sources in 1993 to that in 1995?
Provide a short and direct response. 0.8. What is the ratio of the Electricity production(% of total) in Hydroelectric sources in 1993 to that in 1996?
Your answer should be compact. 1.14. What is the ratio of the Electricity production(% of total) of Nuclear sources in 1993 to that in 1996?
Make the answer very short. 1.04. What is the ratio of the Electricity production(% of total) in Renewable sources in 1993 to that in 1996?
Provide a succinct answer. 0.84. What is the ratio of the Electricity production(% of total) of Hydroelectric sources in 1993 to that in 1997?
Ensure brevity in your answer.  0.93. What is the ratio of the Electricity production(% of total) of Nuclear sources in 1993 to that in 1997?
Offer a very short reply. 0.98. What is the ratio of the Electricity production(% of total) of Hydroelectric sources in 1994 to that in 1995?
Ensure brevity in your answer.  1.05. What is the ratio of the Electricity production(% of total) of Nuclear sources in 1994 to that in 1995?
Provide a succinct answer. 1.01. What is the ratio of the Electricity production(% of total) of Renewable sources in 1994 to that in 1995?
Ensure brevity in your answer.  0.79. What is the ratio of the Electricity production(% of total) of Hydroelectric sources in 1994 to that in 1996?
Your answer should be compact. 1.52. What is the ratio of the Electricity production(% of total) of Nuclear sources in 1994 to that in 1996?
Offer a very short reply. 0.99. What is the ratio of the Electricity production(% of total) of Renewable sources in 1994 to that in 1996?
Provide a succinct answer. 0.83. What is the ratio of the Electricity production(% of total) in Hydroelectric sources in 1994 to that in 1997?
Keep it short and to the point. 1.24. What is the ratio of the Electricity production(% of total) in Nuclear sources in 1994 to that in 1997?
Offer a terse response. 0.94. What is the ratio of the Electricity production(% of total) in Renewable sources in 1994 to that in 1997?
Offer a terse response. 0.98. What is the ratio of the Electricity production(% of total) of Hydroelectric sources in 1995 to that in 1996?
Your response must be concise. 1.45. What is the ratio of the Electricity production(% of total) of Nuclear sources in 1995 to that in 1996?
Provide a succinct answer. 0.98. What is the ratio of the Electricity production(% of total) of Renewable sources in 1995 to that in 1996?
Provide a short and direct response. 1.05. What is the ratio of the Electricity production(% of total) of Hydroelectric sources in 1995 to that in 1997?
Keep it short and to the point. 1.17. What is the ratio of the Electricity production(% of total) of Nuclear sources in 1995 to that in 1997?
Your answer should be very brief. 0.92. What is the ratio of the Electricity production(% of total) of Renewable sources in 1995 to that in 1997?
Offer a terse response. 1.24. What is the ratio of the Electricity production(% of total) of Hydroelectric sources in 1996 to that in 1997?
Your answer should be compact. 0.81. What is the ratio of the Electricity production(% of total) in Nuclear sources in 1996 to that in 1997?
Give a very brief answer. 0.95. What is the ratio of the Electricity production(% of total) in Renewable sources in 1996 to that in 1997?
Provide a succinct answer. 1.18. What is the difference between the highest and the second highest Electricity production(% of total) of Hydroelectric sources?
Offer a terse response. 0.01. What is the difference between the highest and the second highest Electricity production(% of total) in Nuclear sources?
Ensure brevity in your answer.  0.74. What is the difference between the highest and the second highest Electricity production(% of total) of Renewable sources?
Ensure brevity in your answer.  0.02. What is the difference between the highest and the lowest Electricity production(% of total) in Hydroelectric sources?
Keep it short and to the point. 0.17. What is the difference between the highest and the lowest Electricity production(% of total) of Nuclear sources?
Offer a very short reply. 5.38. What is the difference between the highest and the lowest Electricity production(% of total) in Renewable sources?
Keep it short and to the point. 0.15. 